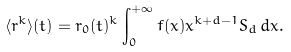<formula> <loc_0><loc_0><loc_500><loc_500>\langle r ^ { k } \rangle ( t ) = r _ { 0 } ( t ) ^ { k } \int _ { 0 } ^ { + \infty } f ( x ) x ^ { k + d - 1 } S _ { d } \, d x .</formula> 